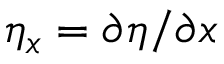<formula> <loc_0><loc_0><loc_500><loc_500>\eta _ { x } = \partial { \eta } / \partial x</formula> 